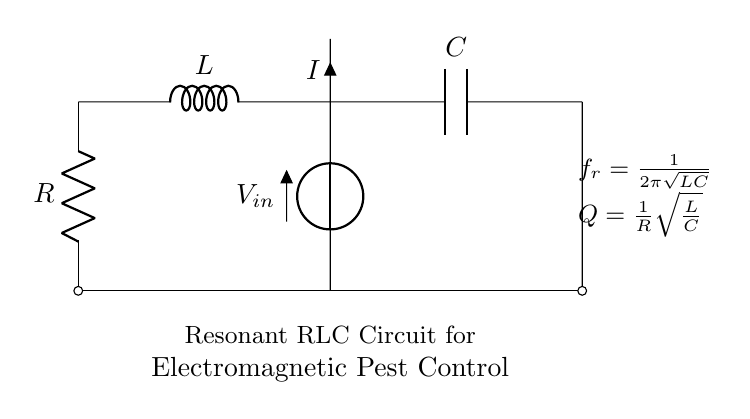What components are present in the circuit? The circuit consists of a resistor, an inductor, and a capacitor. These components are standard parts of an RLC circuit. They are labeled R, L, and C in the diagram.
Answer: Resistor, Inductor, Capacitor What is the function of the inductor in this circuit? The inductor in this circuit is responsible for storing energy in a magnetic field when electrical current flows through it. It resists changes in current and affects the frequency response of the circuit.
Answer: Energy storage What does the variable Q represent in the circuit? In the context of the RLC circuit, Q stands for the quality factor, which indicates how underdamped the circuit is. It is a measure of the energy loss relative to the energy stored. It can be computed using the value of the resistor and the inductance and capacitance values.
Answer: Quality factor Which formula provides the resonant frequency of the circuit? The resonant frequency formula given is f_r equals one divided by two pi times the square root of the product of the inductance and capacitance. This calculates the frequency at which the circuit naturally oscillates.
Answer: f_r = one over two pi times square root of LC How does increasing the resistance affect the quality factor Q? Increasing resistance decreases the quality factor Q. This is because Q is inversely proportional to R, as shown in the formula for Q. A higher resistance translates into greater energy loss, which reduces the circuit's ability to resonate effectively.
Answer: Decreases Q What happens to the current when the circuit reaches resonance? At resonance, the impedance of the RLC circuit is minimized, which results in maximum current flow through the circuit. This creates a very efficient transfer of energy at the resonant frequency.
Answer: Maximum current flow 